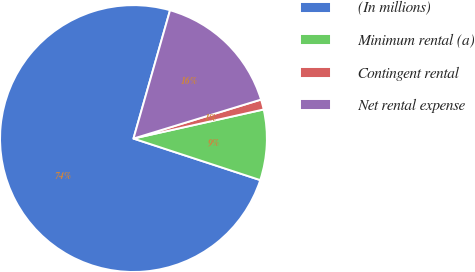Convert chart to OTSL. <chart><loc_0><loc_0><loc_500><loc_500><pie_chart><fcel>(In millions)<fcel>Minimum rental (a)<fcel>Contingent rental<fcel>Net rental expense<nl><fcel>74.38%<fcel>8.54%<fcel>1.22%<fcel>15.86%<nl></chart> 